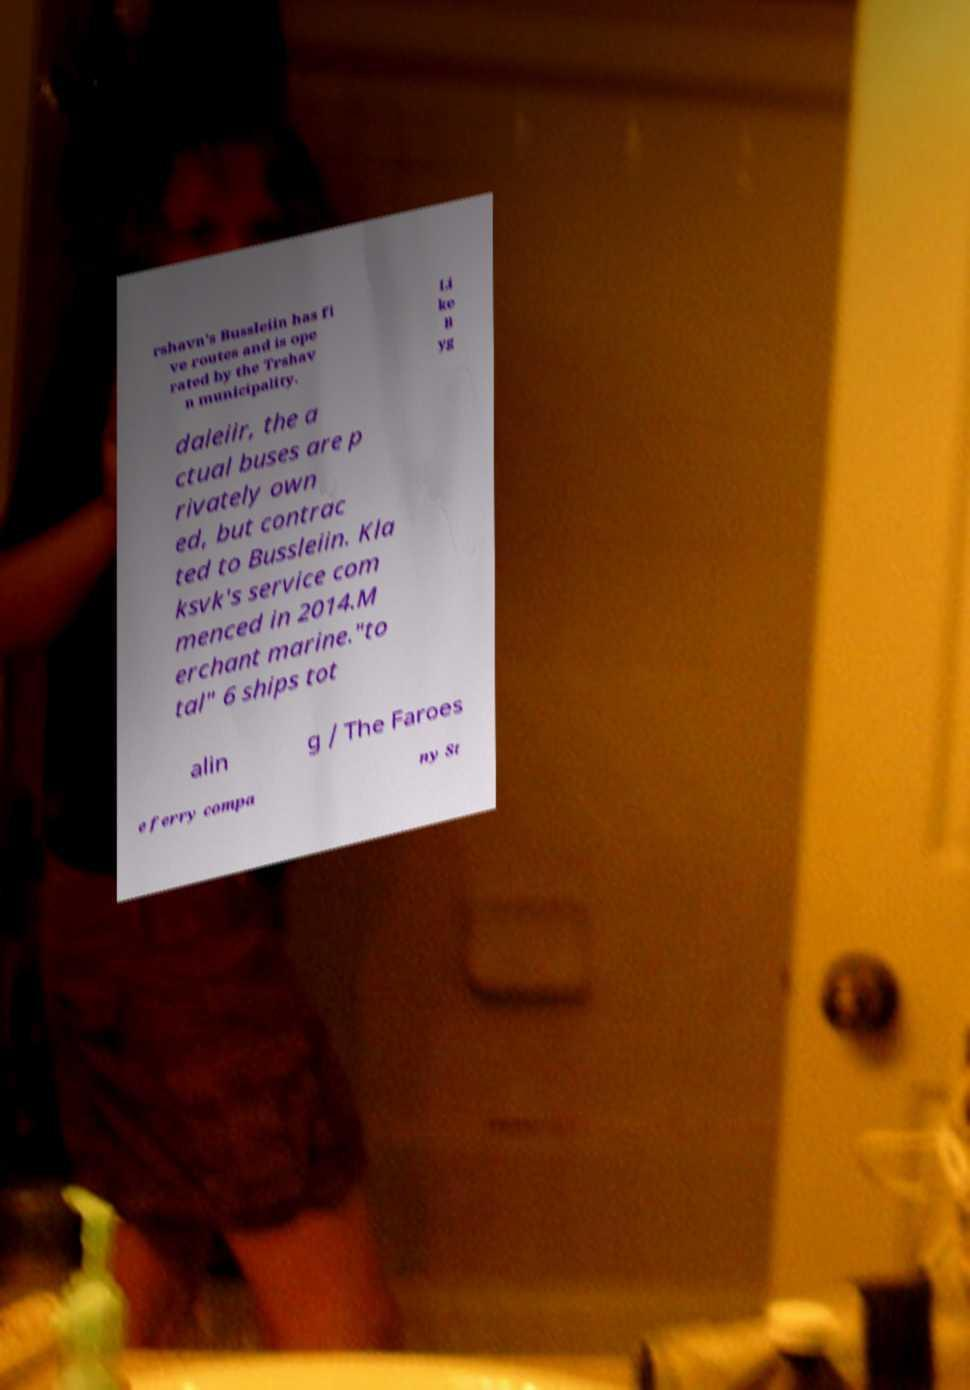Please read and relay the text visible in this image. What does it say? rshavn's Bussleiin has fi ve routes and is ope rated by the Trshav n municipality. Li ke B yg daleiir, the a ctual buses are p rivately own ed, but contrac ted to Bussleiin. Kla ksvk's service com menced in 2014.M erchant marine."to tal" 6 ships tot alin g / The Faroes e ferry compa ny St 